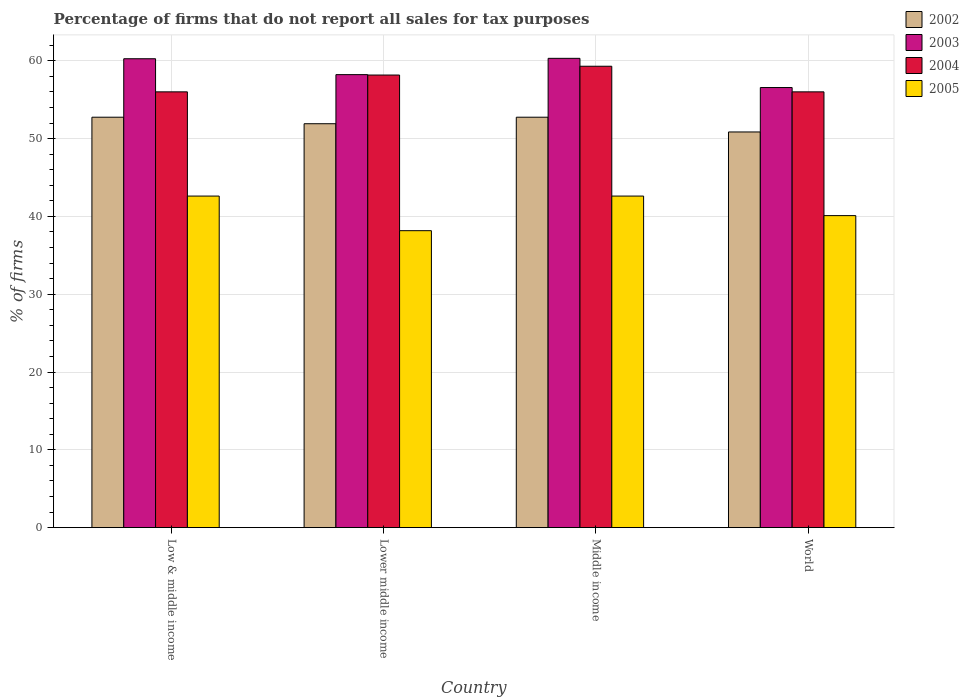How many different coloured bars are there?
Your answer should be very brief. 4. How many groups of bars are there?
Keep it short and to the point. 4. Are the number of bars on each tick of the X-axis equal?
Offer a terse response. Yes. How many bars are there on the 4th tick from the left?
Make the answer very short. 4. How many bars are there on the 1st tick from the right?
Ensure brevity in your answer.  4. In how many cases, is the number of bars for a given country not equal to the number of legend labels?
Offer a very short reply. 0. What is the percentage of firms that do not report all sales for tax purposes in 2005 in Low & middle income?
Keep it short and to the point. 42.61. Across all countries, what is the maximum percentage of firms that do not report all sales for tax purposes in 2003?
Keep it short and to the point. 60.31. Across all countries, what is the minimum percentage of firms that do not report all sales for tax purposes in 2003?
Make the answer very short. 56.56. In which country was the percentage of firms that do not report all sales for tax purposes in 2003 maximum?
Ensure brevity in your answer.  Middle income. In which country was the percentage of firms that do not report all sales for tax purposes in 2005 minimum?
Provide a short and direct response. Lower middle income. What is the total percentage of firms that do not report all sales for tax purposes in 2005 in the graph?
Provide a succinct answer. 163.48. What is the difference between the percentage of firms that do not report all sales for tax purposes in 2002 in Lower middle income and that in Middle income?
Your response must be concise. -0.84. What is the difference between the percentage of firms that do not report all sales for tax purposes in 2005 in Lower middle income and the percentage of firms that do not report all sales for tax purposes in 2002 in World?
Provide a succinct answer. -12.69. What is the average percentage of firms that do not report all sales for tax purposes in 2005 per country?
Your answer should be very brief. 40.87. What is the difference between the percentage of firms that do not report all sales for tax purposes of/in 2002 and percentage of firms that do not report all sales for tax purposes of/in 2004 in Low & middle income?
Give a very brief answer. -3.26. In how many countries, is the percentage of firms that do not report all sales for tax purposes in 2003 greater than 60 %?
Your response must be concise. 2. What is the ratio of the percentage of firms that do not report all sales for tax purposes in 2003 in Lower middle income to that in Middle income?
Make the answer very short. 0.97. Is the percentage of firms that do not report all sales for tax purposes in 2004 in Lower middle income less than that in World?
Offer a very short reply. No. Is the difference between the percentage of firms that do not report all sales for tax purposes in 2002 in Middle income and World greater than the difference between the percentage of firms that do not report all sales for tax purposes in 2004 in Middle income and World?
Keep it short and to the point. No. What is the difference between the highest and the second highest percentage of firms that do not report all sales for tax purposes in 2002?
Provide a short and direct response. -0.84. What is the difference between the highest and the lowest percentage of firms that do not report all sales for tax purposes in 2005?
Offer a very short reply. 4.45. In how many countries, is the percentage of firms that do not report all sales for tax purposes in 2004 greater than the average percentage of firms that do not report all sales for tax purposes in 2004 taken over all countries?
Keep it short and to the point. 2. Is the sum of the percentage of firms that do not report all sales for tax purposes in 2004 in Lower middle income and Middle income greater than the maximum percentage of firms that do not report all sales for tax purposes in 2002 across all countries?
Make the answer very short. Yes. Is it the case that in every country, the sum of the percentage of firms that do not report all sales for tax purposes in 2002 and percentage of firms that do not report all sales for tax purposes in 2003 is greater than the sum of percentage of firms that do not report all sales for tax purposes in 2005 and percentage of firms that do not report all sales for tax purposes in 2004?
Keep it short and to the point. No. Is it the case that in every country, the sum of the percentage of firms that do not report all sales for tax purposes in 2005 and percentage of firms that do not report all sales for tax purposes in 2004 is greater than the percentage of firms that do not report all sales for tax purposes in 2002?
Ensure brevity in your answer.  Yes. How many bars are there?
Provide a short and direct response. 16. Are all the bars in the graph horizontal?
Provide a short and direct response. No. What is the difference between two consecutive major ticks on the Y-axis?
Provide a succinct answer. 10. Are the values on the major ticks of Y-axis written in scientific E-notation?
Offer a very short reply. No. Does the graph contain grids?
Offer a very short reply. Yes. What is the title of the graph?
Your response must be concise. Percentage of firms that do not report all sales for tax purposes. Does "1982" appear as one of the legend labels in the graph?
Ensure brevity in your answer.  No. What is the label or title of the X-axis?
Make the answer very short. Country. What is the label or title of the Y-axis?
Make the answer very short. % of firms. What is the % of firms of 2002 in Low & middle income?
Make the answer very short. 52.75. What is the % of firms of 2003 in Low & middle income?
Offer a very short reply. 60.26. What is the % of firms in 2004 in Low & middle income?
Give a very brief answer. 56.01. What is the % of firms of 2005 in Low & middle income?
Your response must be concise. 42.61. What is the % of firms of 2002 in Lower middle income?
Make the answer very short. 51.91. What is the % of firms in 2003 in Lower middle income?
Provide a short and direct response. 58.22. What is the % of firms of 2004 in Lower middle income?
Keep it short and to the point. 58.16. What is the % of firms of 2005 in Lower middle income?
Your answer should be compact. 38.16. What is the % of firms in 2002 in Middle income?
Provide a succinct answer. 52.75. What is the % of firms of 2003 in Middle income?
Provide a succinct answer. 60.31. What is the % of firms in 2004 in Middle income?
Make the answer very short. 59.3. What is the % of firms in 2005 in Middle income?
Offer a terse response. 42.61. What is the % of firms of 2002 in World?
Keep it short and to the point. 50.85. What is the % of firms of 2003 in World?
Your response must be concise. 56.56. What is the % of firms in 2004 in World?
Give a very brief answer. 56.01. What is the % of firms in 2005 in World?
Give a very brief answer. 40.1. Across all countries, what is the maximum % of firms of 2002?
Offer a terse response. 52.75. Across all countries, what is the maximum % of firms of 2003?
Offer a very short reply. 60.31. Across all countries, what is the maximum % of firms in 2004?
Keep it short and to the point. 59.3. Across all countries, what is the maximum % of firms in 2005?
Make the answer very short. 42.61. Across all countries, what is the minimum % of firms of 2002?
Provide a succinct answer. 50.85. Across all countries, what is the minimum % of firms in 2003?
Your answer should be very brief. 56.56. Across all countries, what is the minimum % of firms in 2004?
Give a very brief answer. 56.01. Across all countries, what is the minimum % of firms in 2005?
Make the answer very short. 38.16. What is the total % of firms in 2002 in the graph?
Offer a very short reply. 208.25. What is the total % of firms of 2003 in the graph?
Ensure brevity in your answer.  235.35. What is the total % of firms of 2004 in the graph?
Provide a succinct answer. 229.47. What is the total % of firms in 2005 in the graph?
Offer a terse response. 163.48. What is the difference between the % of firms of 2002 in Low & middle income and that in Lower middle income?
Make the answer very short. 0.84. What is the difference between the % of firms of 2003 in Low & middle income and that in Lower middle income?
Your response must be concise. 2.04. What is the difference between the % of firms of 2004 in Low & middle income and that in Lower middle income?
Provide a succinct answer. -2.16. What is the difference between the % of firms in 2005 in Low & middle income and that in Lower middle income?
Offer a very short reply. 4.45. What is the difference between the % of firms of 2003 in Low & middle income and that in Middle income?
Provide a succinct answer. -0.05. What is the difference between the % of firms in 2004 in Low & middle income and that in Middle income?
Give a very brief answer. -3.29. What is the difference between the % of firms in 2005 in Low & middle income and that in Middle income?
Your response must be concise. 0. What is the difference between the % of firms of 2002 in Low & middle income and that in World?
Ensure brevity in your answer.  1.89. What is the difference between the % of firms of 2004 in Low & middle income and that in World?
Give a very brief answer. 0. What is the difference between the % of firms in 2005 in Low & middle income and that in World?
Your answer should be very brief. 2.51. What is the difference between the % of firms in 2002 in Lower middle income and that in Middle income?
Provide a succinct answer. -0.84. What is the difference between the % of firms in 2003 in Lower middle income and that in Middle income?
Make the answer very short. -2.09. What is the difference between the % of firms of 2004 in Lower middle income and that in Middle income?
Your response must be concise. -1.13. What is the difference between the % of firms in 2005 in Lower middle income and that in Middle income?
Offer a terse response. -4.45. What is the difference between the % of firms in 2002 in Lower middle income and that in World?
Provide a short and direct response. 1.06. What is the difference between the % of firms in 2003 in Lower middle income and that in World?
Provide a succinct answer. 1.66. What is the difference between the % of firms of 2004 in Lower middle income and that in World?
Ensure brevity in your answer.  2.16. What is the difference between the % of firms in 2005 in Lower middle income and that in World?
Offer a terse response. -1.94. What is the difference between the % of firms of 2002 in Middle income and that in World?
Provide a succinct answer. 1.89. What is the difference between the % of firms of 2003 in Middle income and that in World?
Provide a succinct answer. 3.75. What is the difference between the % of firms of 2004 in Middle income and that in World?
Give a very brief answer. 3.29. What is the difference between the % of firms of 2005 in Middle income and that in World?
Make the answer very short. 2.51. What is the difference between the % of firms in 2002 in Low & middle income and the % of firms in 2003 in Lower middle income?
Provide a short and direct response. -5.47. What is the difference between the % of firms of 2002 in Low & middle income and the % of firms of 2004 in Lower middle income?
Keep it short and to the point. -5.42. What is the difference between the % of firms of 2002 in Low & middle income and the % of firms of 2005 in Lower middle income?
Give a very brief answer. 14.58. What is the difference between the % of firms in 2003 in Low & middle income and the % of firms in 2004 in Lower middle income?
Provide a succinct answer. 2.1. What is the difference between the % of firms in 2003 in Low & middle income and the % of firms in 2005 in Lower middle income?
Make the answer very short. 22.1. What is the difference between the % of firms of 2004 in Low & middle income and the % of firms of 2005 in Lower middle income?
Your answer should be very brief. 17.84. What is the difference between the % of firms in 2002 in Low & middle income and the % of firms in 2003 in Middle income?
Your answer should be compact. -7.57. What is the difference between the % of firms in 2002 in Low & middle income and the % of firms in 2004 in Middle income?
Offer a terse response. -6.55. What is the difference between the % of firms in 2002 in Low & middle income and the % of firms in 2005 in Middle income?
Provide a succinct answer. 10.13. What is the difference between the % of firms of 2003 in Low & middle income and the % of firms of 2005 in Middle income?
Your answer should be very brief. 17.65. What is the difference between the % of firms of 2004 in Low & middle income and the % of firms of 2005 in Middle income?
Give a very brief answer. 13.39. What is the difference between the % of firms in 2002 in Low & middle income and the % of firms in 2003 in World?
Your response must be concise. -3.81. What is the difference between the % of firms of 2002 in Low & middle income and the % of firms of 2004 in World?
Your answer should be compact. -3.26. What is the difference between the % of firms of 2002 in Low & middle income and the % of firms of 2005 in World?
Provide a short and direct response. 12.65. What is the difference between the % of firms in 2003 in Low & middle income and the % of firms in 2004 in World?
Your response must be concise. 4.25. What is the difference between the % of firms in 2003 in Low & middle income and the % of firms in 2005 in World?
Your response must be concise. 20.16. What is the difference between the % of firms of 2004 in Low & middle income and the % of firms of 2005 in World?
Offer a very short reply. 15.91. What is the difference between the % of firms in 2002 in Lower middle income and the % of firms in 2003 in Middle income?
Keep it short and to the point. -8.4. What is the difference between the % of firms in 2002 in Lower middle income and the % of firms in 2004 in Middle income?
Provide a short and direct response. -7.39. What is the difference between the % of firms of 2002 in Lower middle income and the % of firms of 2005 in Middle income?
Keep it short and to the point. 9.3. What is the difference between the % of firms of 2003 in Lower middle income and the % of firms of 2004 in Middle income?
Your answer should be compact. -1.08. What is the difference between the % of firms in 2003 in Lower middle income and the % of firms in 2005 in Middle income?
Your response must be concise. 15.61. What is the difference between the % of firms of 2004 in Lower middle income and the % of firms of 2005 in Middle income?
Offer a terse response. 15.55. What is the difference between the % of firms of 2002 in Lower middle income and the % of firms of 2003 in World?
Your response must be concise. -4.65. What is the difference between the % of firms of 2002 in Lower middle income and the % of firms of 2004 in World?
Give a very brief answer. -4.1. What is the difference between the % of firms in 2002 in Lower middle income and the % of firms in 2005 in World?
Provide a succinct answer. 11.81. What is the difference between the % of firms in 2003 in Lower middle income and the % of firms in 2004 in World?
Provide a succinct answer. 2.21. What is the difference between the % of firms in 2003 in Lower middle income and the % of firms in 2005 in World?
Your answer should be very brief. 18.12. What is the difference between the % of firms of 2004 in Lower middle income and the % of firms of 2005 in World?
Keep it short and to the point. 18.07. What is the difference between the % of firms in 2002 in Middle income and the % of firms in 2003 in World?
Make the answer very short. -3.81. What is the difference between the % of firms of 2002 in Middle income and the % of firms of 2004 in World?
Keep it short and to the point. -3.26. What is the difference between the % of firms in 2002 in Middle income and the % of firms in 2005 in World?
Provide a succinct answer. 12.65. What is the difference between the % of firms of 2003 in Middle income and the % of firms of 2004 in World?
Your answer should be compact. 4.31. What is the difference between the % of firms in 2003 in Middle income and the % of firms in 2005 in World?
Your answer should be compact. 20.21. What is the difference between the % of firms in 2004 in Middle income and the % of firms in 2005 in World?
Make the answer very short. 19.2. What is the average % of firms of 2002 per country?
Provide a short and direct response. 52.06. What is the average % of firms in 2003 per country?
Your answer should be very brief. 58.84. What is the average % of firms of 2004 per country?
Give a very brief answer. 57.37. What is the average % of firms in 2005 per country?
Provide a short and direct response. 40.87. What is the difference between the % of firms in 2002 and % of firms in 2003 in Low & middle income?
Your response must be concise. -7.51. What is the difference between the % of firms of 2002 and % of firms of 2004 in Low & middle income?
Provide a succinct answer. -3.26. What is the difference between the % of firms of 2002 and % of firms of 2005 in Low & middle income?
Your answer should be compact. 10.13. What is the difference between the % of firms in 2003 and % of firms in 2004 in Low & middle income?
Offer a terse response. 4.25. What is the difference between the % of firms in 2003 and % of firms in 2005 in Low & middle income?
Ensure brevity in your answer.  17.65. What is the difference between the % of firms in 2004 and % of firms in 2005 in Low & middle income?
Your response must be concise. 13.39. What is the difference between the % of firms in 2002 and % of firms in 2003 in Lower middle income?
Keep it short and to the point. -6.31. What is the difference between the % of firms of 2002 and % of firms of 2004 in Lower middle income?
Keep it short and to the point. -6.26. What is the difference between the % of firms in 2002 and % of firms in 2005 in Lower middle income?
Your answer should be compact. 13.75. What is the difference between the % of firms in 2003 and % of firms in 2004 in Lower middle income?
Your answer should be very brief. 0.05. What is the difference between the % of firms in 2003 and % of firms in 2005 in Lower middle income?
Provide a short and direct response. 20.06. What is the difference between the % of firms in 2004 and % of firms in 2005 in Lower middle income?
Your answer should be compact. 20. What is the difference between the % of firms of 2002 and % of firms of 2003 in Middle income?
Offer a very short reply. -7.57. What is the difference between the % of firms of 2002 and % of firms of 2004 in Middle income?
Keep it short and to the point. -6.55. What is the difference between the % of firms in 2002 and % of firms in 2005 in Middle income?
Ensure brevity in your answer.  10.13. What is the difference between the % of firms in 2003 and % of firms in 2004 in Middle income?
Your answer should be very brief. 1.02. What is the difference between the % of firms of 2003 and % of firms of 2005 in Middle income?
Offer a very short reply. 17.7. What is the difference between the % of firms of 2004 and % of firms of 2005 in Middle income?
Make the answer very short. 16.69. What is the difference between the % of firms in 2002 and % of firms in 2003 in World?
Make the answer very short. -5.71. What is the difference between the % of firms of 2002 and % of firms of 2004 in World?
Provide a short and direct response. -5.15. What is the difference between the % of firms in 2002 and % of firms in 2005 in World?
Your response must be concise. 10.75. What is the difference between the % of firms of 2003 and % of firms of 2004 in World?
Keep it short and to the point. 0.56. What is the difference between the % of firms of 2003 and % of firms of 2005 in World?
Your response must be concise. 16.46. What is the difference between the % of firms in 2004 and % of firms in 2005 in World?
Give a very brief answer. 15.91. What is the ratio of the % of firms of 2002 in Low & middle income to that in Lower middle income?
Give a very brief answer. 1.02. What is the ratio of the % of firms of 2003 in Low & middle income to that in Lower middle income?
Your answer should be compact. 1.04. What is the ratio of the % of firms in 2004 in Low & middle income to that in Lower middle income?
Provide a short and direct response. 0.96. What is the ratio of the % of firms in 2005 in Low & middle income to that in Lower middle income?
Provide a succinct answer. 1.12. What is the ratio of the % of firms in 2003 in Low & middle income to that in Middle income?
Ensure brevity in your answer.  1. What is the ratio of the % of firms in 2004 in Low & middle income to that in Middle income?
Your answer should be compact. 0.94. What is the ratio of the % of firms of 2002 in Low & middle income to that in World?
Give a very brief answer. 1.04. What is the ratio of the % of firms of 2003 in Low & middle income to that in World?
Make the answer very short. 1.07. What is the ratio of the % of firms of 2005 in Low & middle income to that in World?
Offer a very short reply. 1.06. What is the ratio of the % of firms in 2002 in Lower middle income to that in Middle income?
Your answer should be compact. 0.98. What is the ratio of the % of firms in 2003 in Lower middle income to that in Middle income?
Provide a succinct answer. 0.97. What is the ratio of the % of firms of 2004 in Lower middle income to that in Middle income?
Make the answer very short. 0.98. What is the ratio of the % of firms of 2005 in Lower middle income to that in Middle income?
Offer a terse response. 0.9. What is the ratio of the % of firms in 2002 in Lower middle income to that in World?
Give a very brief answer. 1.02. What is the ratio of the % of firms of 2003 in Lower middle income to that in World?
Offer a very short reply. 1.03. What is the ratio of the % of firms of 2004 in Lower middle income to that in World?
Give a very brief answer. 1.04. What is the ratio of the % of firms in 2005 in Lower middle income to that in World?
Your answer should be compact. 0.95. What is the ratio of the % of firms of 2002 in Middle income to that in World?
Provide a succinct answer. 1.04. What is the ratio of the % of firms of 2003 in Middle income to that in World?
Give a very brief answer. 1.07. What is the ratio of the % of firms in 2004 in Middle income to that in World?
Offer a terse response. 1.06. What is the ratio of the % of firms of 2005 in Middle income to that in World?
Your answer should be very brief. 1.06. What is the difference between the highest and the second highest % of firms of 2002?
Provide a succinct answer. 0. What is the difference between the highest and the second highest % of firms of 2003?
Your response must be concise. 0.05. What is the difference between the highest and the second highest % of firms in 2004?
Make the answer very short. 1.13. What is the difference between the highest and the lowest % of firms of 2002?
Offer a very short reply. 1.89. What is the difference between the highest and the lowest % of firms in 2003?
Offer a terse response. 3.75. What is the difference between the highest and the lowest % of firms in 2004?
Keep it short and to the point. 3.29. What is the difference between the highest and the lowest % of firms in 2005?
Your response must be concise. 4.45. 